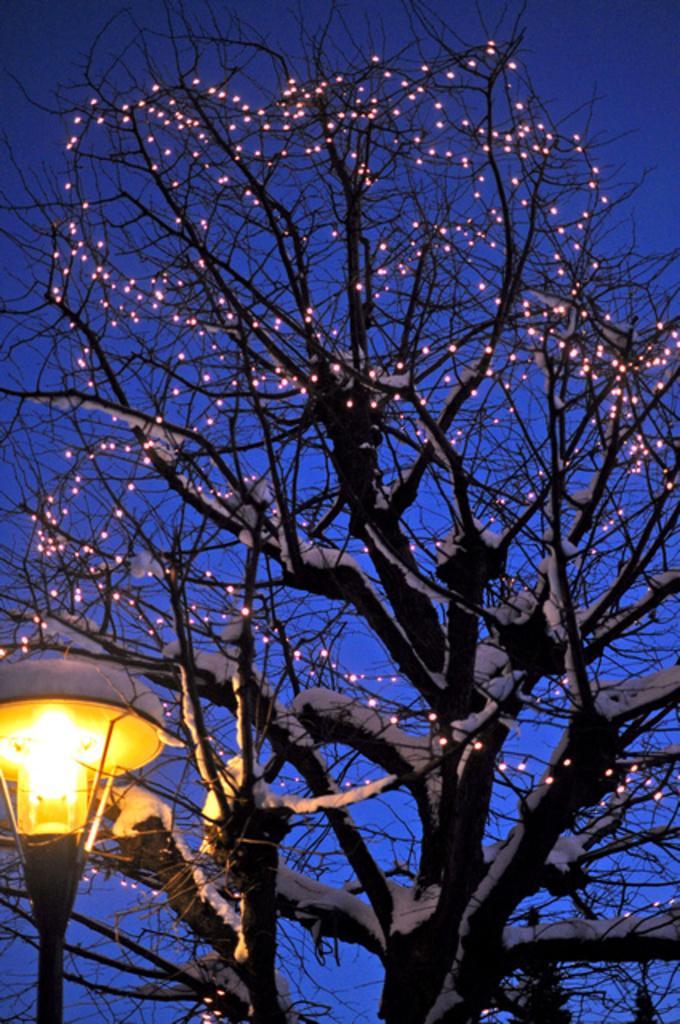In one or two sentences, can you explain what this image depicts? In this picture there is a tree and there are lights on the tree. At the top there is sky. At the bottom left there is a street light. 